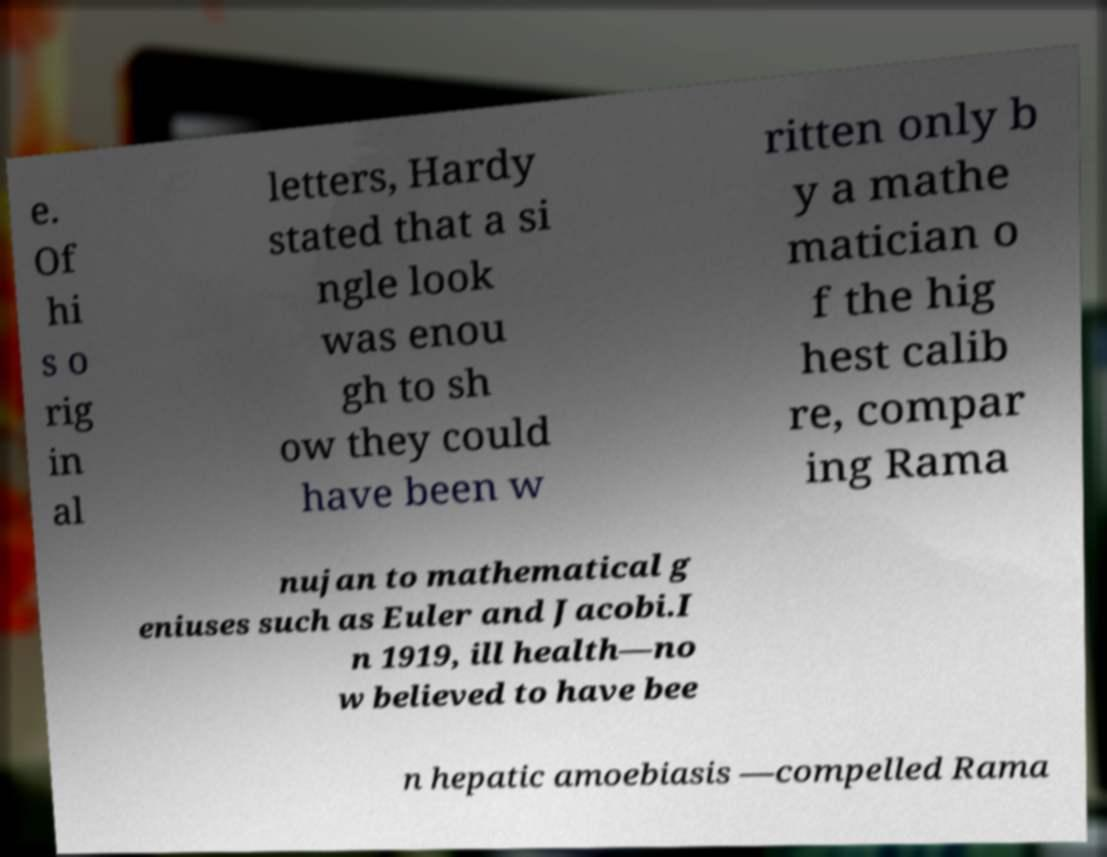Please read and relay the text visible in this image. What does it say? e. Of hi s o rig in al letters, Hardy stated that a si ngle look was enou gh to sh ow they could have been w ritten only b y a mathe matician o f the hig hest calib re, compar ing Rama nujan to mathematical g eniuses such as Euler and Jacobi.I n 1919, ill health—no w believed to have bee n hepatic amoebiasis —compelled Rama 